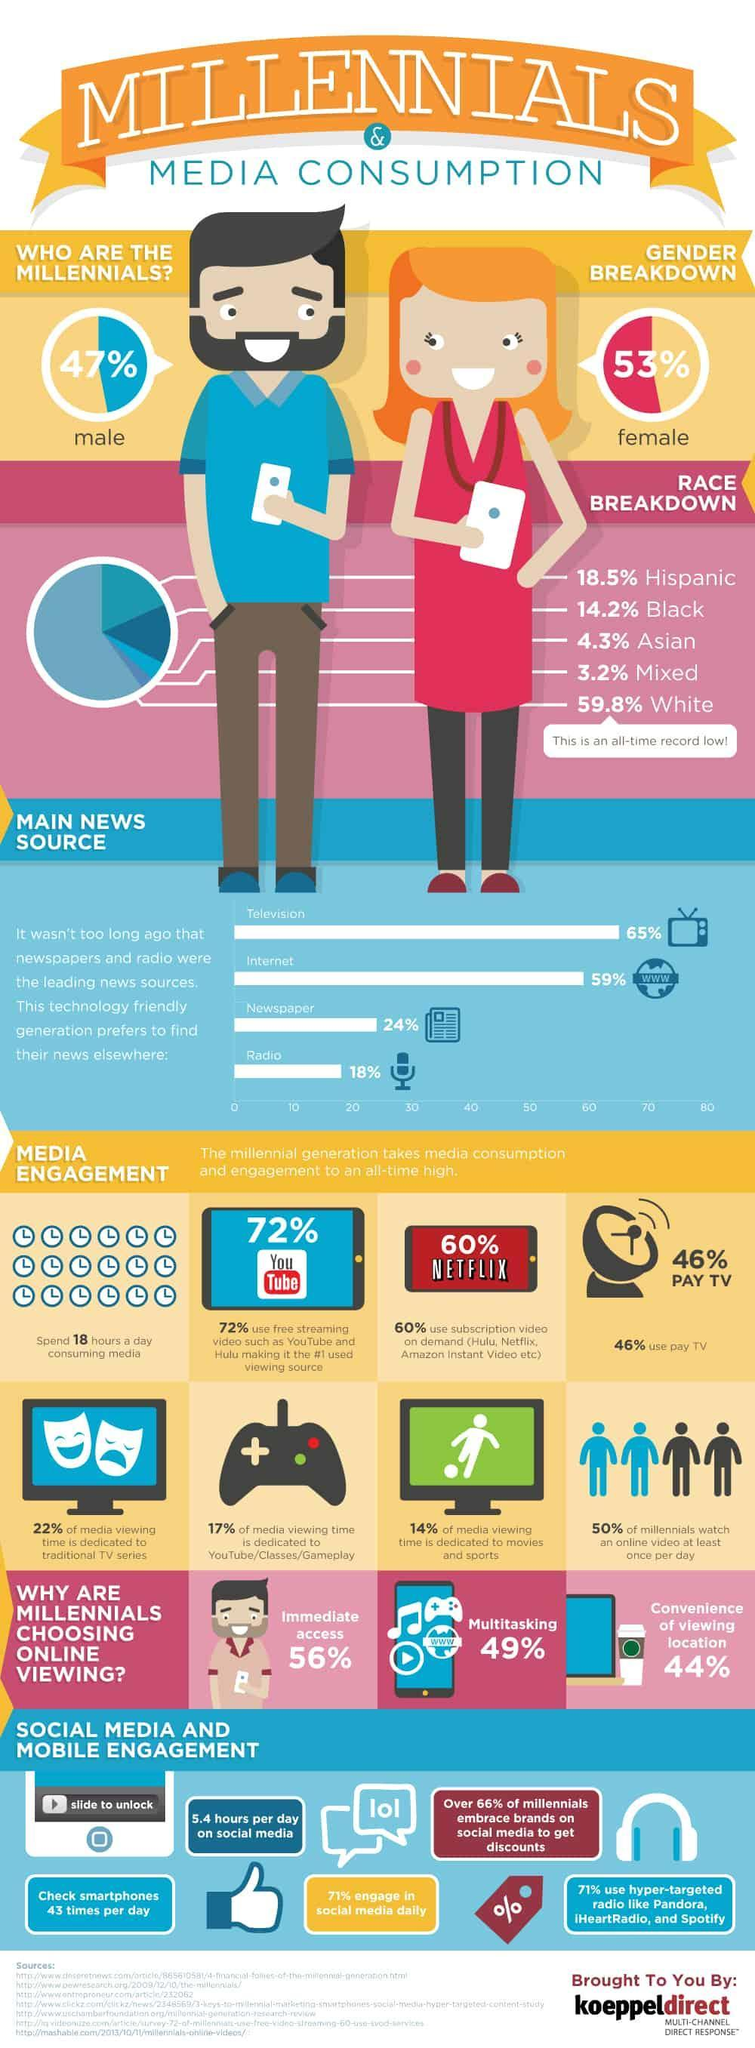What percentage of the millennials in the U.S. choose online viewing for the convenience of viewing location?
Answer the question with a short phrase. 44% What percent of the millennials in the U.S. are male? 47% What percent of the millennials in the U.S. do not engage in the social media activities daily? 29% Why do the majority of the millennials in the U.S. choose online viewing? Immediate access What percent of the millennials in the U.S. are Blacks? 14.2% What percent of the millennials in the U.S. are female? 53% What percent of the millennials in the U.S. find news on the internet? 59% What percentage of the millennials in the U.S. do not use pay TV? 54% Which ethnic group does the majority of the millennial belong to? White What percent of the millennials in the U.S. are Asian? 4.3% 